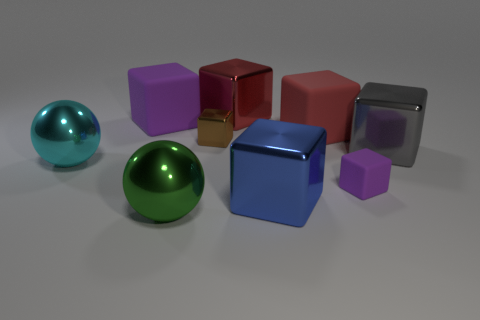Are there any metallic blocks behind the big sphere that is behind the big green sphere?
Provide a succinct answer. Yes. What number of big red cubes are the same material as the big purple cube?
Offer a very short reply. 1. How big is the purple rubber cube that is to the right of the red block that is on the left side of the big rubber object that is in front of the large purple object?
Your answer should be compact. Small. There is a big gray cube; how many purple matte blocks are behind it?
Ensure brevity in your answer.  1. Are there more big metallic balls than gray metallic objects?
Your answer should be very brief. Yes. There is another object that is the same color as the small rubber object; what size is it?
Keep it short and to the point. Large. There is a cube that is both to the left of the big red shiny block and on the right side of the large purple block; what size is it?
Offer a very short reply. Small. The ball that is behind the purple block that is in front of the block that is to the left of the big green shiny thing is made of what material?
Your response must be concise. Metal. What is the material of the object that is the same color as the small rubber cube?
Provide a short and direct response. Rubber. Is the color of the cube that is left of the brown metallic object the same as the small object right of the big blue thing?
Offer a terse response. Yes. 